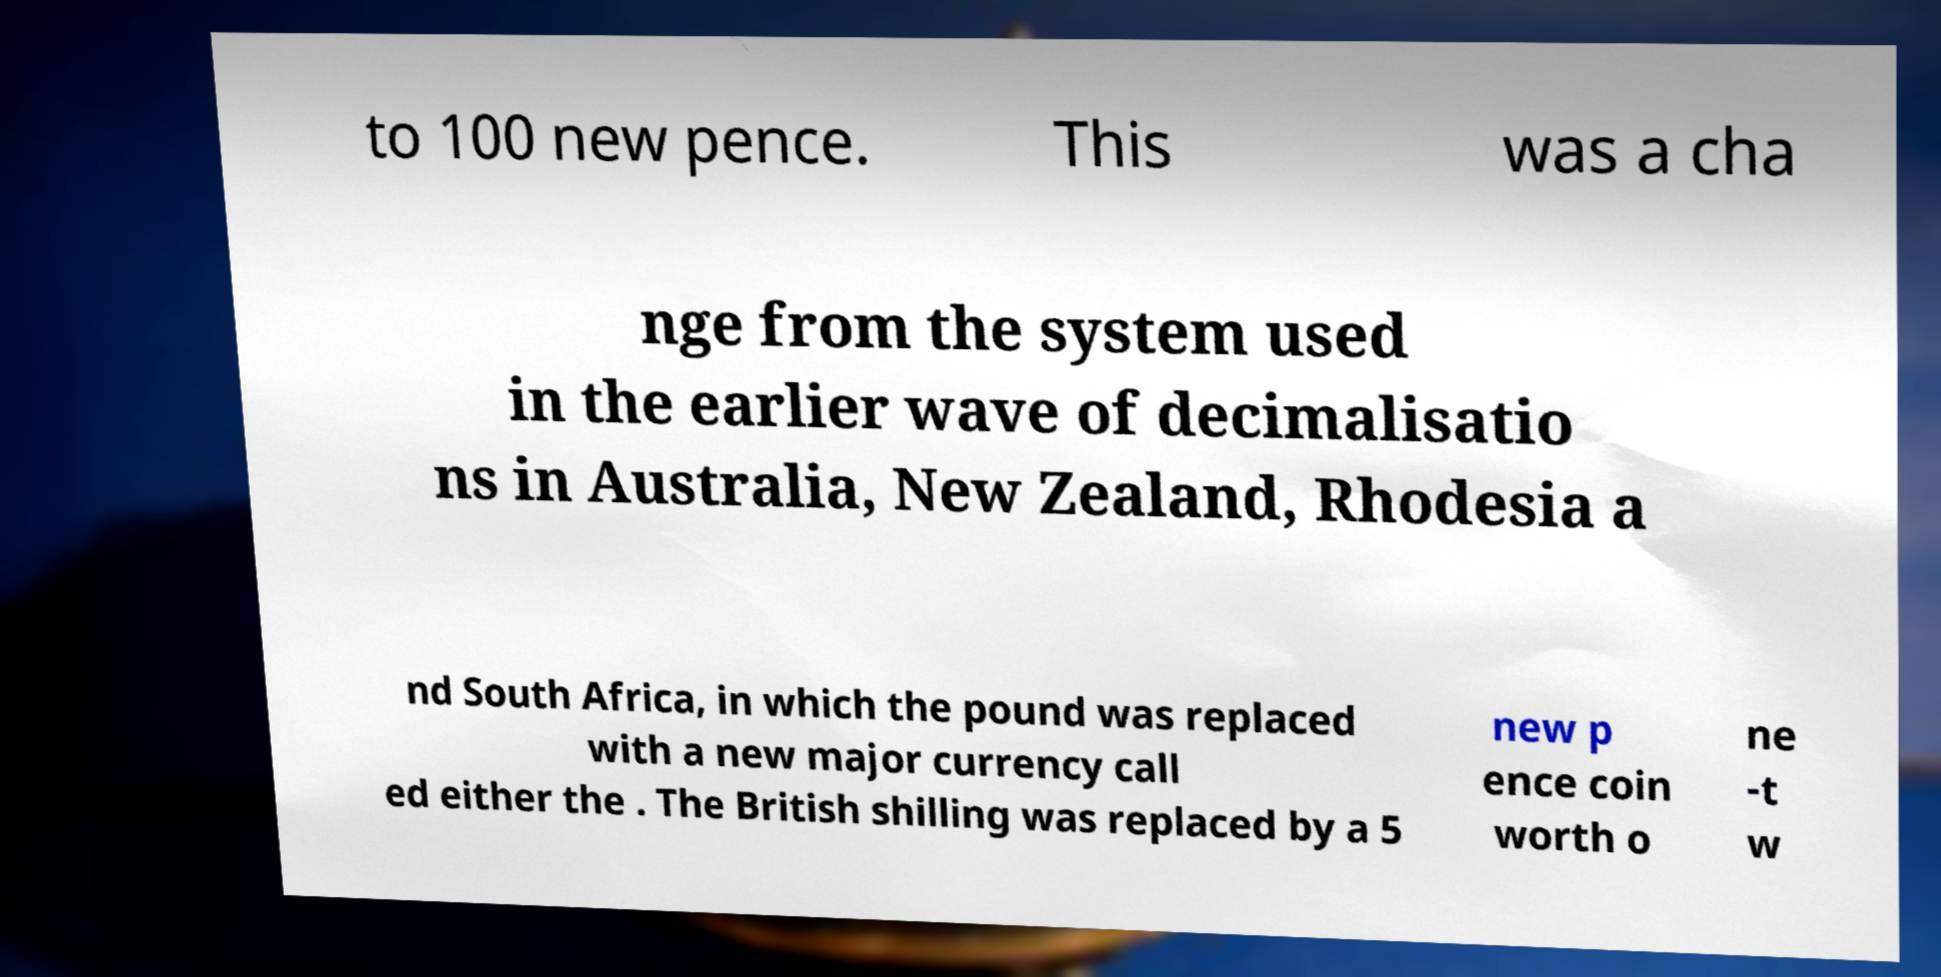Please read and relay the text visible in this image. What does it say? to 100 new pence. This was a cha nge from the system used in the earlier wave of decimalisatio ns in Australia, New Zealand, Rhodesia a nd South Africa, in which the pound was replaced with a new major currency call ed either the . The British shilling was replaced by a 5 new p ence coin worth o ne -t w 